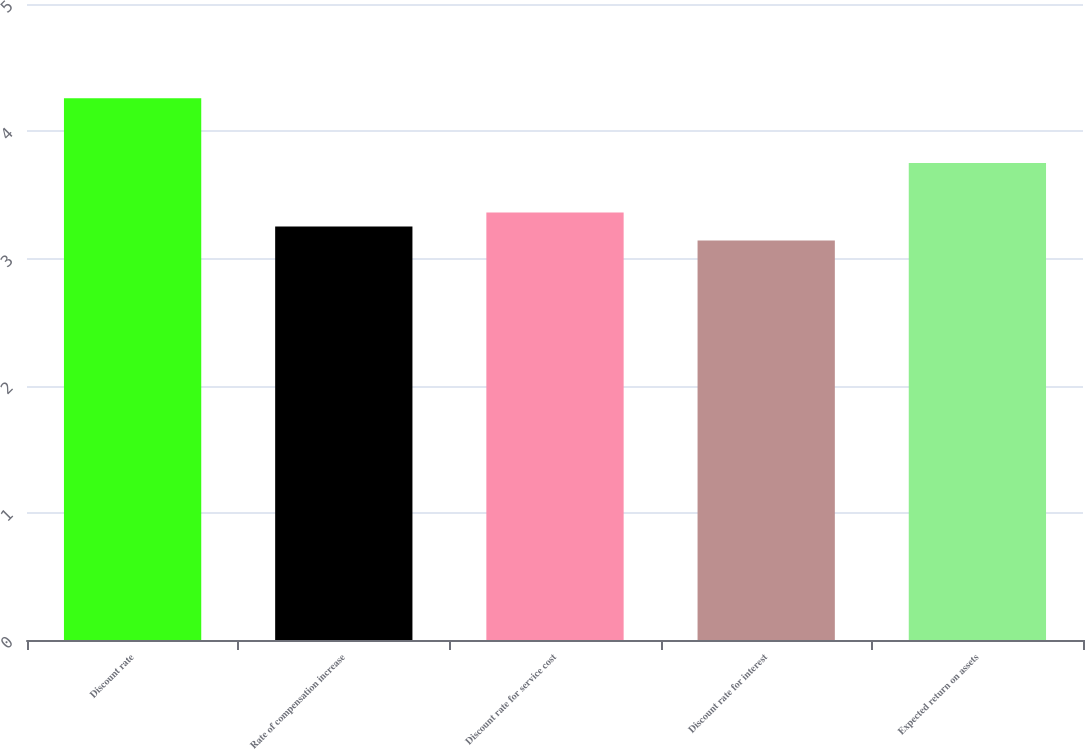Convert chart. <chart><loc_0><loc_0><loc_500><loc_500><bar_chart><fcel>Discount rate<fcel>Rate of compensation increase<fcel>Discount rate for service cost<fcel>Discount rate for interest<fcel>Expected return on assets<nl><fcel>4.26<fcel>3.25<fcel>3.36<fcel>3.14<fcel>3.75<nl></chart> 